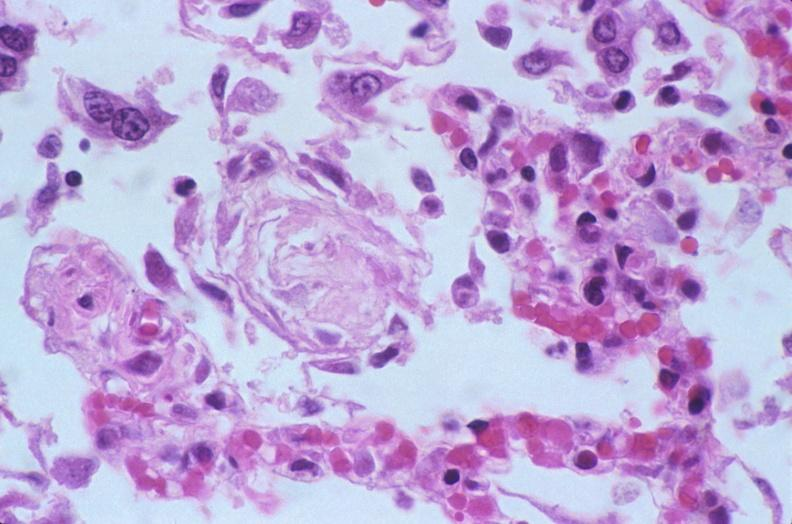does this image show lung, diffuse alveolar damage?
Answer the question using a single word or phrase. Yes 